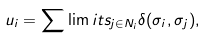Convert formula to latex. <formula><loc_0><loc_0><loc_500><loc_500>u _ { i } = \sum \lim i t s _ { j \in N _ { i } } \delta ( \sigma _ { i } , \sigma _ { j } ) ,</formula> 